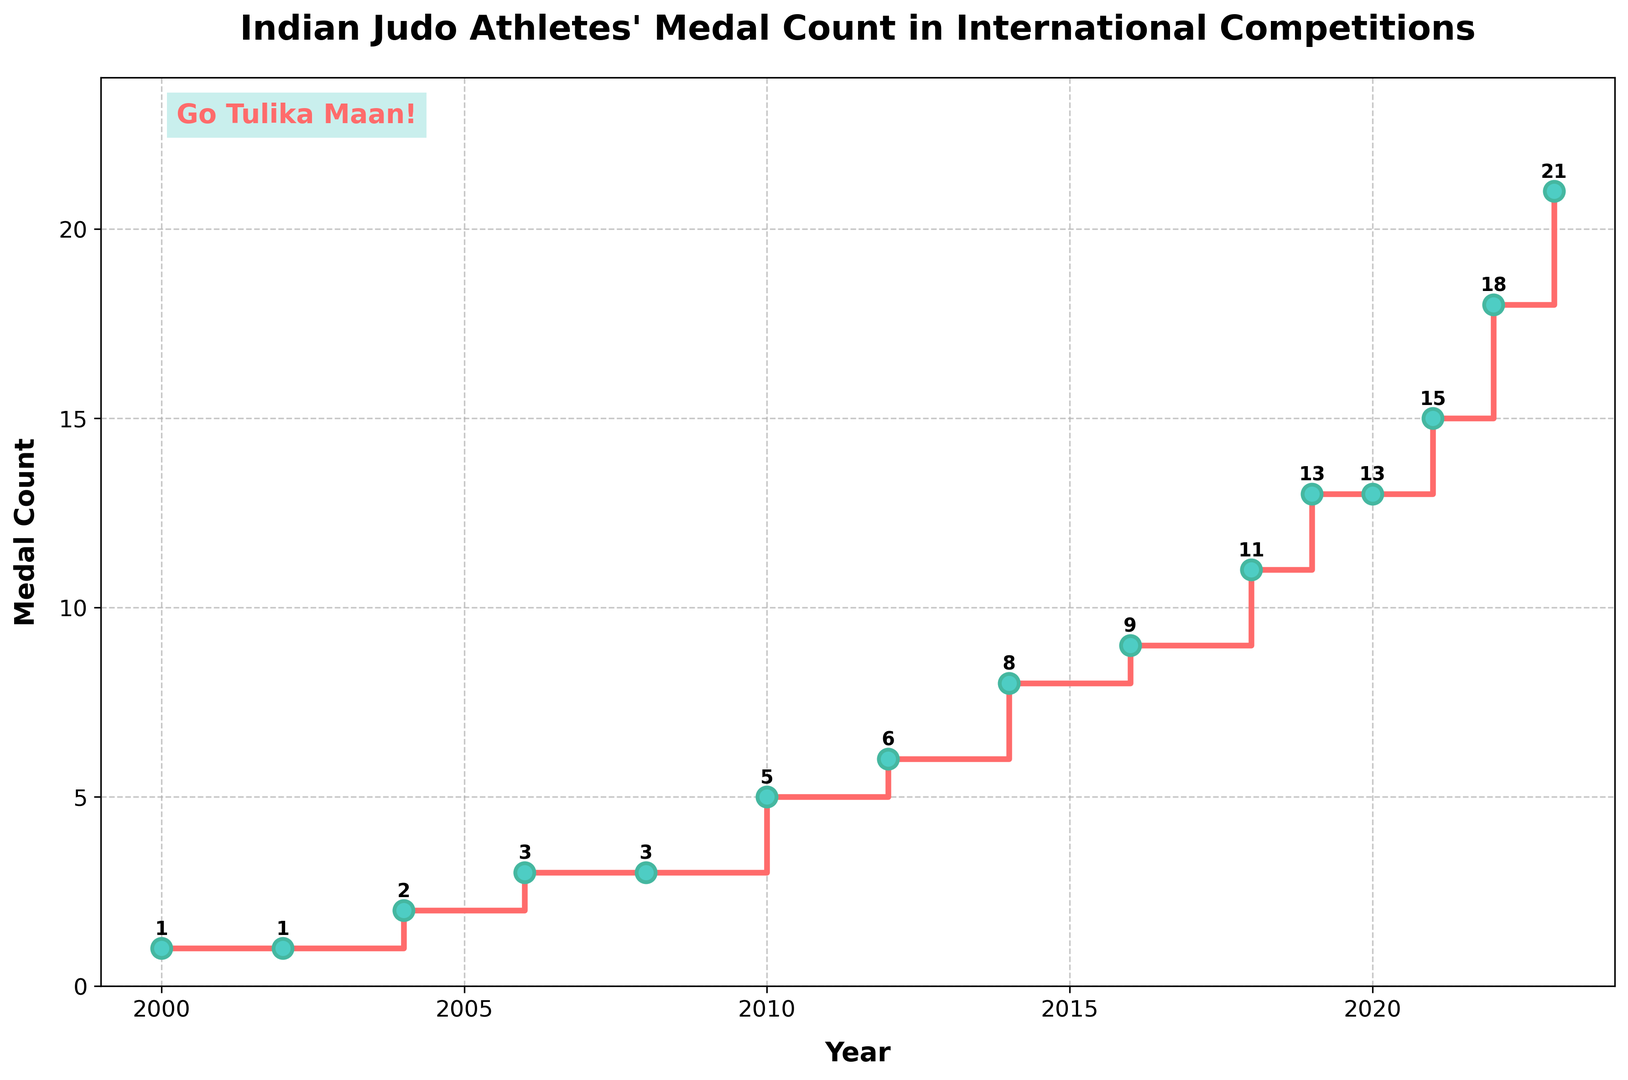When did Indian judo athletes first win more than 10 medals in international competitions? According to the plot, the first year when the medal count exceeds 10 is 2018.
Answer: 2018 Which year had the highest medal count for Indian judo athletes? The plot shows an increasing trend in the medal count, with the highest value being 21 in 2023.
Answer: 2023 How many medals did Indian judo athletes win in 2008? The plot shows a stair that reaches 3 medals at the end of 2008.
Answer: 3 By how many medals did the count increase from 2010 to 2014? The medal count in 2010 was 5, and in 2014 it was 8. Therefore, the increase was 8 - 5 = 3 medals.
Answer: 3 Did the medal count increase or decrease between 2019 and 2020? By how much? The plot shows that the medal count remained the same between 2019 (13 medals) and 2020 (13 medals).
Answer: stayed the same, 0 What was the average medal count per year from 2014 to 2018? The medal counts from 2014 to 2018 are 8, 9, 11, and 13. The average is calculated as (8 + 9 + 11 + 13)/4 = 10.25 medals per year.
Answer: 10.25 Between which consecutive years did the medal count increase the most? The largest increase can be observed between 2022 (18 medals) and 2023 (21 medals), an increase of 3 medals.
Answer: between 2022 and 2023 What visual elements are used to annotate the plot and emphasize Tulika Maan's achievement? The plot includes a text annotation "Go Tulika Maan!" in red with a green background, positioned at the top left corner.
Answer: text annotation in red with a green background 